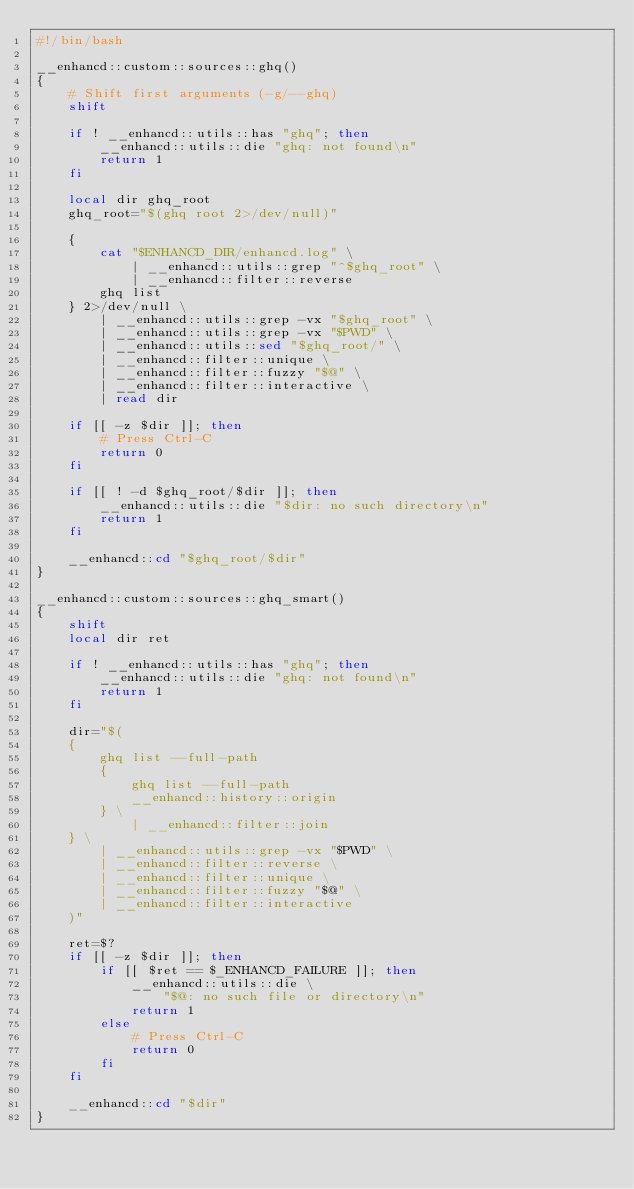<code> <loc_0><loc_0><loc_500><loc_500><_Bash_>#!/bin/bash

__enhancd::custom::sources::ghq()
{
    # Shift first arguments (-g/--ghq)
    shift

    if ! __enhancd::utils::has "ghq"; then
        __enhancd::utils::die "ghq: not found\n"
        return 1
    fi

    local dir ghq_root
    ghq_root="$(ghq root 2>/dev/null)"

    {
        cat "$ENHANCD_DIR/enhancd.log" \
            | __enhancd::utils::grep "^$ghq_root" \
            | __enhancd::filter::reverse
        ghq list
    } 2>/dev/null \
        | __enhancd::utils::grep -vx "$ghq_root" \
        | __enhancd::utils::grep -vx "$PWD" \
        | __enhancd::utils::sed "$ghq_root/" \
        | __enhancd::filter::unique \
        | __enhancd::filter::fuzzy "$@" \
        | __enhancd::filter::interactive \
        | read dir

    if [[ -z $dir ]]; then
        # Press Ctrl-C
        return 0
    fi

    if [[ ! -d $ghq_root/$dir ]]; then
        __enhancd::utils::die "$dir: no such directory\n"
        return 1
    fi

    __enhancd::cd "$ghq_root/$dir"
}

__enhancd::custom::sources::ghq_smart()
{
    shift
    local dir ret

    if ! __enhancd::utils::has "ghq"; then
        __enhancd::utils::die "ghq: not found\n"
        return 1
    fi

    dir="$(
    {
        ghq list --full-path
        {
            ghq list --full-path
            __enhancd::history::origin
        } \
            | __enhancd::filter::join
    } \
        | __enhancd::utils::grep -vx "$PWD" \
        | __enhancd::filter::reverse \
        | __enhancd::filter::unique \
        | __enhancd::filter::fuzzy "$@" \
        | __enhancd::filter::interactive
    )"

    ret=$?
    if [[ -z $dir ]]; then
        if [[ $ret == $_ENHANCD_FAILURE ]]; then
            __enhancd::utils::die \
                "$@: no such file or directory\n"
            return 1
        else
            # Press Ctrl-C
            return 0
        fi
    fi

    __enhancd::cd "$dir"
}
</code> 